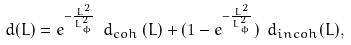<formula> <loc_0><loc_0><loc_500><loc_500>d ( L ) = e ^ { - \frac { L ^ { 2 } } { L _ { \phi } ^ { 2 } } } \ d _ { c o h } \left ( L \right ) + ( 1 - e ^ { - \frac { L ^ { 2 } } { L _ { \phi } ^ { 2 } } } ) \ d _ { i n c o h } ( L ) ,</formula> 